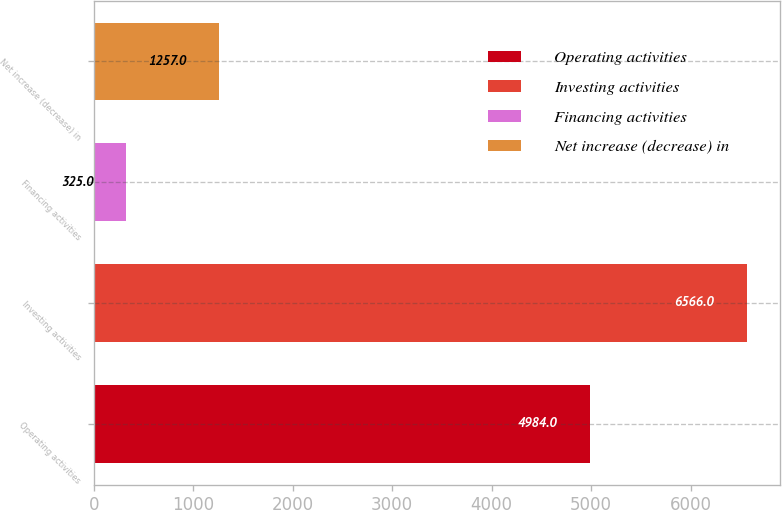<chart> <loc_0><loc_0><loc_500><loc_500><bar_chart><fcel>Operating activities<fcel>Investing activities<fcel>Financing activities<fcel>Net increase (decrease) in<nl><fcel>4984<fcel>6566<fcel>325<fcel>1257<nl></chart> 